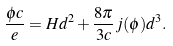<formula> <loc_0><loc_0><loc_500><loc_500>\frac { \phi c } { e } = H d ^ { 2 } + \frac { 8 \pi } { 3 c } j ( \phi ) d ^ { 3 } .</formula> 